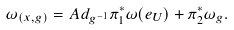Convert formula to latex. <formula><loc_0><loc_0><loc_500><loc_500>\omega _ { ( x , g ) } = A d _ { g ^ { - 1 } } \pi _ { 1 } ^ { * } \omega ( e _ { U } ) + \pi _ { 2 } ^ { * } \omega _ { g } .</formula> 